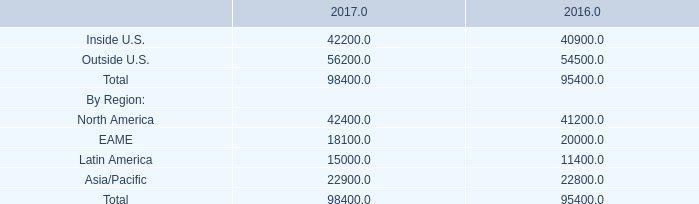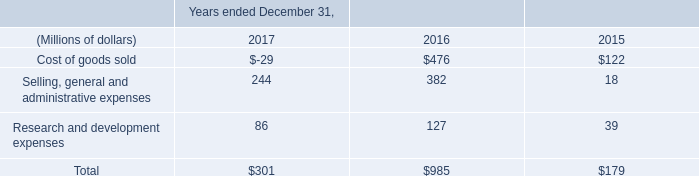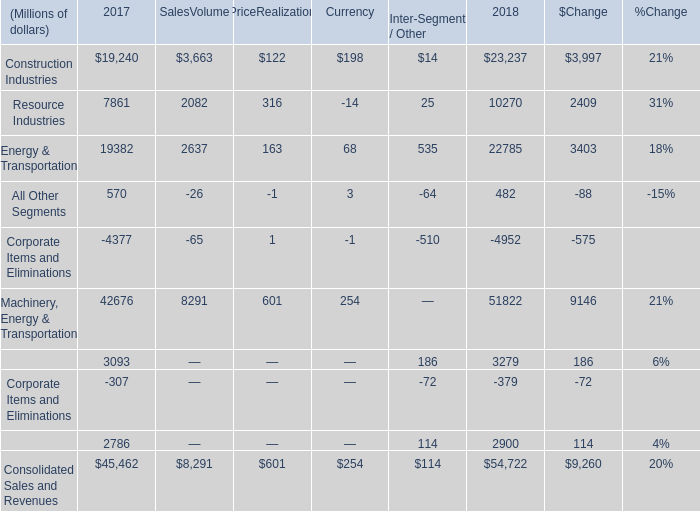What is the total amount of Outside U.S. of 2017, Resource Industries of SalesVolume, and Financial Products Revenues of 2018 ? 
Computations: ((56200.0 + 2082.0) + 2900.0)
Answer: 61182.0. 